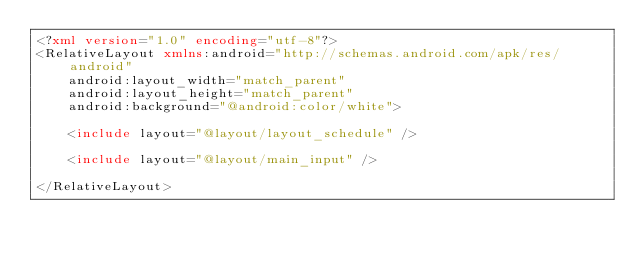Convert code to text. <code><loc_0><loc_0><loc_500><loc_500><_XML_><?xml version="1.0" encoding="utf-8"?>
<RelativeLayout xmlns:android="http://schemas.android.com/apk/res/android"
    android:layout_width="match_parent"
    android:layout_height="match_parent"
    android:background="@android:color/white">

    <include layout="@layout/layout_schedule" />

    <include layout="@layout/main_input" />

</RelativeLayout>

</code> 